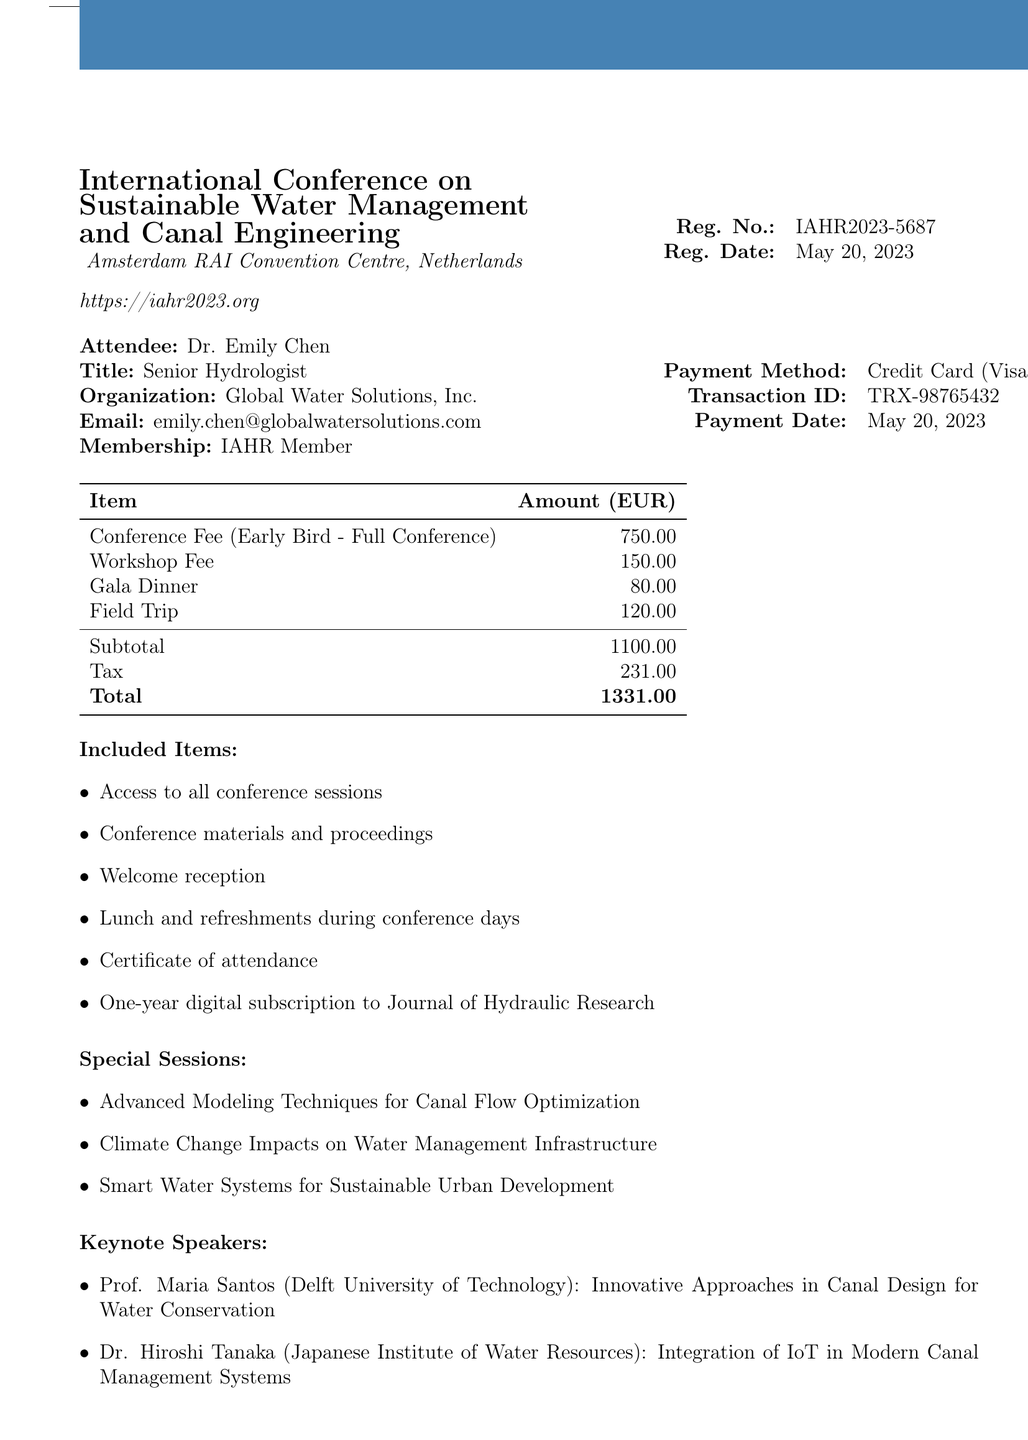What is the name of the conference? The name of the conference is stated in the document as "International Conference on Sustainable Water Management and Canal Engineering."
Answer: International Conference on Sustainable Water Management and Canal Engineering What is the registration number? The registration number is provided in the document, which specifically states "IAHR2023-5687."
Answer: IAHR2023-5687 What is the total amount paid? The total amount paid is listed in the fee breakdown section, which states "Total 1331.00."
Answer: 1331.00 Who is a keynote speaker? The document lists keynote speakers, including Prof. Maria Santos and Dr. Hiroshi Tanaka.
Answer: Prof. Maria Santos What is the workshop fee? The fee breakdown specifies the workshop fee as "150.00."
Answer: 150.00 What special discount is offered? The document mentions a special discount of "10% off for IAHR members."
Answer: 10% off for IAHR members What date was the payment made? The payment date is clearly indicated in the payment information section as "May 20, 2023."
Answer: May 20, 2023 What type of accommodation is suggested? The document provides additional information, specifically mentioning "NH Amsterdam Centre" as the accommodation partner.
Answer: NH Amsterdam Centre What is included in the conference registration? The document lists included items that state access to conference sessions and materials, among others.
Answer: Access to all conference sessions 